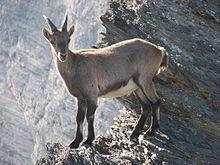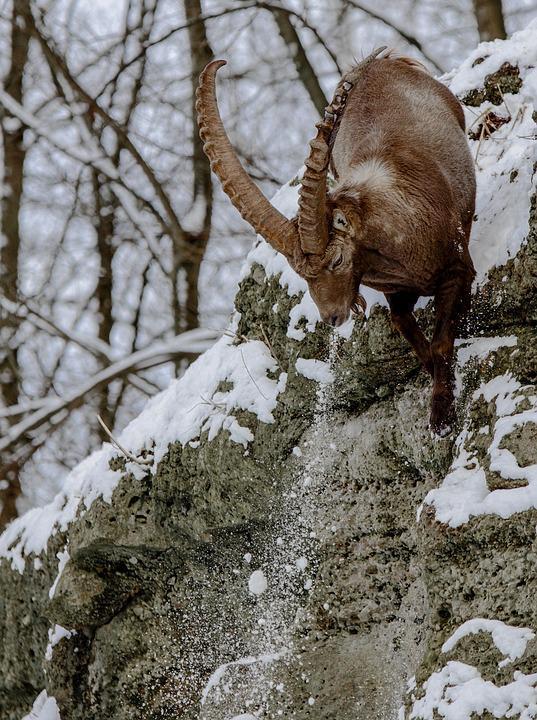The first image is the image on the left, the second image is the image on the right. Assess this claim about the two images: "In one image, two animals with large upright horns are perched on a high rocky area.". Correct or not? Answer yes or no. No. The first image is the image on the left, the second image is the image on the right. Considering the images on both sides, is "There are 2 goats on the mountain." valid? Answer yes or no. Yes. 